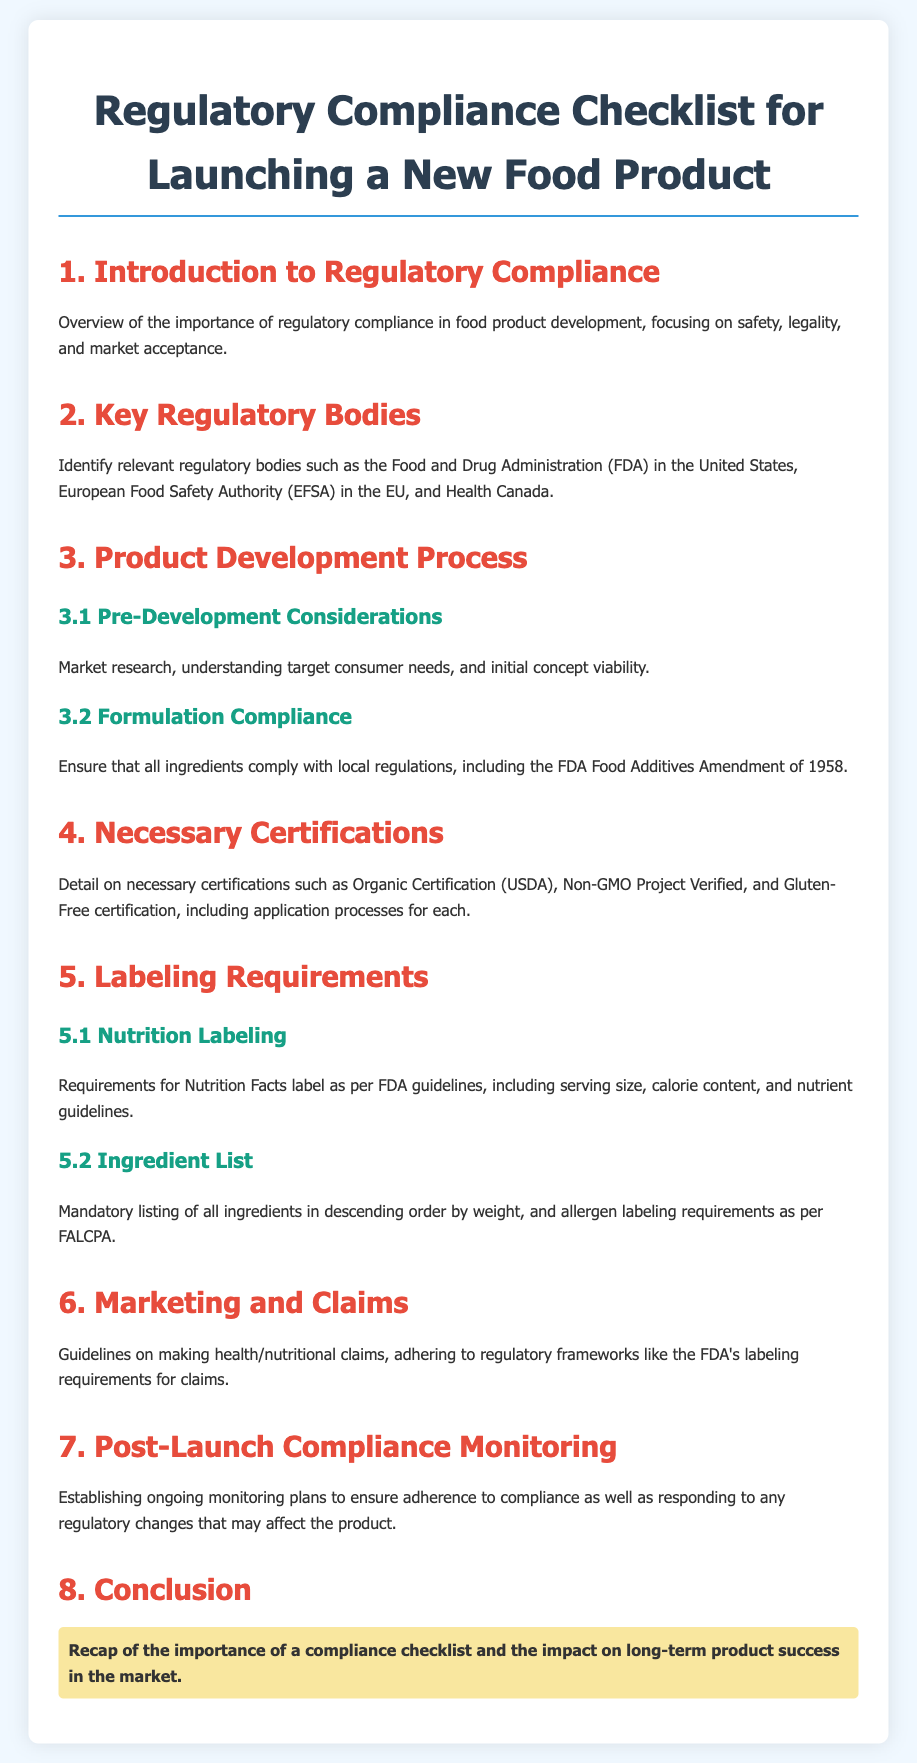What is the title of the document? The title is located at the top of the document, specifying the focus of the content.
Answer: Regulatory Compliance Checklist for Launching a New Food Product Which regulatory body is mentioned for the United States? The document lists relevant regulatory bodies, including the one specific to the United States.
Answer: Food and Drug Administration (FDA) What certification involves organically grown products? The document lists necessary certifications and mentions one for organic products.
Answer: Organic Certification (USDA) What is the core focus of Section 1? Section 1 gives an overview of what the document addresses regarding compliance in food product development.
Answer: Importance of regulatory compliance According to the document, what is required in the Nutrition Facts label? The section on Nutrition Labeling outlines essential details that must be included per regulatory guidelines.
Answer: Serving size, calorie content, and nutrient guidelines What is the order for listing ingredients on food labels? The document specifies how ingredients should be listed for proper compliance.
Answer: Descending order by weight What must health claims adhere to? The document outlines how claims should align with regulatory frameworks relating to marketing.
Answer: FDA's labeling requirements What is necessary for ongoing compliance after product launch? The document suggests monitoring plans for post-launch activities to ensure regulatory adherence.
Answer: Compliance monitoring plans 